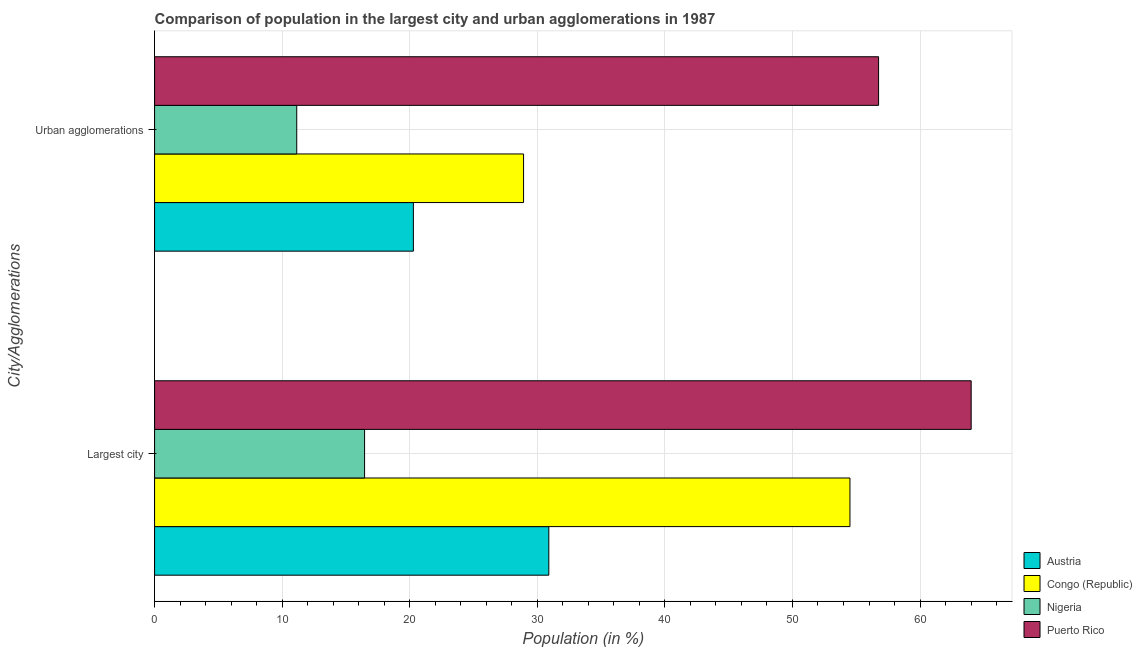How many different coloured bars are there?
Make the answer very short. 4. Are the number of bars per tick equal to the number of legend labels?
Make the answer very short. Yes. How many bars are there on the 1st tick from the bottom?
Offer a very short reply. 4. What is the label of the 1st group of bars from the top?
Keep it short and to the point. Urban agglomerations. What is the population in urban agglomerations in Nigeria?
Keep it short and to the point. 11.14. Across all countries, what is the maximum population in urban agglomerations?
Provide a short and direct response. 56.75. Across all countries, what is the minimum population in urban agglomerations?
Provide a succinct answer. 11.14. In which country was the population in the largest city maximum?
Provide a short and direct response. Puerto Rico. In which country was the population in urban agglomerations minimum?
Your answer should be very brief. Nigeria. What is the total population in the largest city in the graph?
Keep it short and to the point. 165.88. What is the difference between the population in the largest city in Puerto Rico and that in Austria?
Provide a succinct answer. 33.11. What is the difference between the population in urban agglomerations in Nigeria and the population in the largest city in Congo (Republic)?
Give a very brief answer. -43.36. What is the average population in the largest city per country?
Keep it short and to the point. 41.47. What is the difference between the population in urban agglomerations and population in the largest city in Congo (Republic)?
Provide a succinct answer. -25.58. What is the ratio of the population in the largest city in Austria to that in Nigeria?
Your answer should be compact. 1.88. Is the population in the largest city in Nigeria less than that in Austria?
Give a very brief answer. Yes. In how many countries, is the population in the largest city greater than the average population in the largest city taken over all countries?
Ensure brevity in your answer.  2. What does the 2nd bar from the top in Urban agglomerations represents?
Your answer should be very brief. Nigeria. What does the 3rd bar from the bottom in Urban agglomerations represents?
Offer a terse response. Nigeria. How many countries are there in the graph?
Provide a succinct answer. 4. What is the difference between two consecutive major ticks on the X-axis?
Your response must be concise. 10. Are the values on the major ticks of X-axis written in scientific E-notation?
Make the answer very short. No. Does the graph contain any zero values?
Provide a short and direct response. No. Does the graph contain grids?
Make the answer very short. Yes. Where does the legend appear in the graph?
Ensure brevity in your answer.  Bottom right. What is the title of the graph?
Your response must be concise. Comparison of population in the largest city and urban agglomerations in 1987. What is the label or title of the X-axis?
Make the answer very short. Population (in %). What is the label or title of the Y-axis?
Offer a terse response. City/Agglomerations. What is the Population (in %) in Austria in Largest city?
Offer a very short reply. 30.9. What is the Population (in %) of Congo (Republic) in Largest city?
Offer a very short reply. 54.51. What is the Population (in %) in Nigeria in Largest city?
Offer a very short reply. 16.46. What is the Population (in %) in Puerto Rico in Largest city?
Your response must be concise. 64.01. What is the Population (in %) in Austria in Urban agglomerations?
Your response must be concise. 20.29. What is the Population (in %) of Congo (Republic) in Urban agglomerations?
Give a very brief answer. 28.92. What is the Population (in %) in Nigeria in Urban agglomerations?
Keep it short and to the point. 11.14. What is the Population (in %) of Puerto Rico in Urban agglomerations?
Your answer should be very brief. 56.75. Across all City/Agglomerations, what is the maximum Population (in %) of Austria?
Give a very brief answer. 30.9. Across all City/Agglomerations, what is the maximum Population (in %) in Congo (Republic)?
Keep it short and to the point. 54.51. Across all City/Agglomerations, what is the maximum Population (in %) in Nigeria?
Provide a succinct answer. 16.46. Across all City/Agglomerations, what is the maximum Population (in %) of Puerto Rico?
Your answer should be very brief. 64.01. Across all City/Agglomerations, what is the minimum Population (in %) in Austria?
Provide a short and direct response. 20.29. Across all City/Agglomerations, what is the minimum Population (in %) in Congo (Republic)?
Your answer should be very brief. 28.92. Across all City/Agglomerations, what is the minimum Population (in %) of Nigeria?
Offer a terse response. 11.14. Across all City/Agglomerations, what is the minimum Population (in %) of Puerto Rico?
Your answer should be very brief. 56.75. What is the total Population (in %) in Austria in the graph?
Your response must be concise. 51.19. What is the total Population (in %) in Congo (Republic) in the graph?
Offer a terse response. 83.43. What is the total Population (in %) in Nigeria in the graph?
Ensure brevity in your answer.  27.6. What is the total Population (in %) of Puerto Rico in the graph?
Give a very brief answer. 120.76. What is the difference between the Population (in %) in Austria in Largest city and that in Urban agglomerations?
Ensure brevity in your answer.  10.62. What is the difference between the Population (in %) in Congo (Republic) in Largest city and that in Urban agglomerations?
Offer a terse response. 25.58. What is the difference between the Population (in %) of Nigeria in Largest city and that in Urban agglomerations?
Your response must be concise. 5.32. What is the difference between the Population (in %) in Puerto Rico in Largest city and that in Urban agglomerations?
Offer a very short reply. 7.26. What is the difference between the Population (in %) in Austria in Largest city and the Population (in %) in Congo (Republic) in Urban agglomerations?
Keep it short and to the point. 1.98. What is the difference between the Population (in %) of Austria in Largest city and the Population (in %) of Nigeria in Urban agglomerations?
Give a very brief answer. 19.76. What is the difference between the Population (in %) of Austria in Largest city and the Population (in %) of Puerto Rico in Urban agglomerations?
Give a very brief answer. -25.85. What is the difference between the Population (in %) of Congo (Republic) in Largest city and the Population (in %) of Nigeria in Urban agglomerations?
Your response must be concise. 43.36. What is the difference between the Population (in %) of Congo (Republic) in Largest city and the Population (in %) of Puerto Rico in Urban agglomerations?
Your answer should be very brief. -2.24. What is the difference between the Population (in %) of Nigeria in Largest city and the Population (in %) of Puerto Rico in Urban agglomerations?
Offer a terse response. -40.29. What is the average Population (in %) in Austria per City/Agglomerations?
Offer a terse response. 25.59. What is the average Population (in %) of Congo (Republic) per City/Agglomerations?
Provide a short and direct response. 41.71. What is the average Population (in %) in Nigeria per City/Agglomerations?
Your response must be concise. 13.8. What is the average Population (in %) of Puerto Rico per City/Agglomerations?
Ensure brevity in your answer.  60.38. What is the difference between the Population (in %) of Austria and Population (in %) of Congo (Republic) in Largest city?
Your response must be concise. -23.6. What is the difference between the Population (in %) in Austria and Population (in %) in Nigeria in Largest city?
Your response must be concise. 14.44. What is the difference between the Population (in %) of Austria and Population (in %) of Puerto Rico in Largest city?
Give a very brief answer. -33.11. What is the difference between the Population (in %) of Congo (Republic) and Population (in %) of Nigeria in Largest city?
Ensure brevity in your answer.  38.05. What is the difference between the Population (in %) of Congo (Republic) and Population (in %) of Puerto Rico in Largest city?
Your answer should be very brief. -9.5. What is the difference between the Population (in %) in Nigeria and Population (in %) in Puerto Rico in Largest city?
Provide a succinct answer. -47.55. What is the difference between the Population (in %) in Austria and Population (in %) in Congo (Republic) in Urban agglomerations?
Your response must be concise. -8.64. What is the difference between the Population (in %) in Austria and Population (in %) in Nigeria in Urban agglomerations?
Your response must be concise. 9.14. What is the difference between the Population (in %) of Austria and Population (in %) of Puerto Rico in Urban agglomerations?
Give a very brief answer. -36.46. What is the difference between the Population (in %) in Congo (Republic) and Population (in %) in Nigeria in Urban agglomerations?
Offer a terse response. 17.78. What is the difference between the Population (in %) in Congo (Republic) and Population (in %) in Puerto Rico in Urban agglomerations?
Offer a very short reply. -27.83. What is the difference between the Population (in %) in Nigeria and Population (in %) in Puerto Rico in Urban agglomerations?
Make the answer very short. -45.61. What is the ratio of the Population (in %) of Austria in Largest city to that in Urban agglomerations?
Provide a short and direct response. 1.52. What is the ratio of the Population (in %) in Congo (Republic) in Largest city to that in Urban agglomerations?
Your answer should be very brief. 1.88. What is the ratio of the Population (in %) of Nigeria in Largest city to that in Urban agglomerations?
Provide a succinct answer. 1.48. What is the ratio of the Population (in %) in Puerto Rico in Largest city to that in Urban agglomerations?
Make the answer very short. 1.13. What is the difference between the highest and the second highest Population (in %) of Austria?
Ensure brevity in your answer.  10.62. What is the difference between the highest and the second highest Population (in %) of Congo (Republic)?
Your answer should be compact. 25.58. What is the difference between the highest and the second highest Population (in %) in Nigeria?
Your answer should be very brief. 5.32. What is the difference between the highest and the second highest Population (in %) of Puerto Rico?
Provide a short and direct response. 7.26. What is the difference between the highest and the lowest Population (in %) of Austria?
Offer a terse response. 10.62. What is the difference between the highest and the lowest Population (in %) in Congo (Republic)?
Provide a short and direct response. 25.58. What is the difference between the highest and the lowest Population (in %) of Nigeria?
Offer a very short reply. 5.32. What is the difference between the highest and the lowest Population (in %) of Puerto Rico?
Make the answer very short. 7.26. 